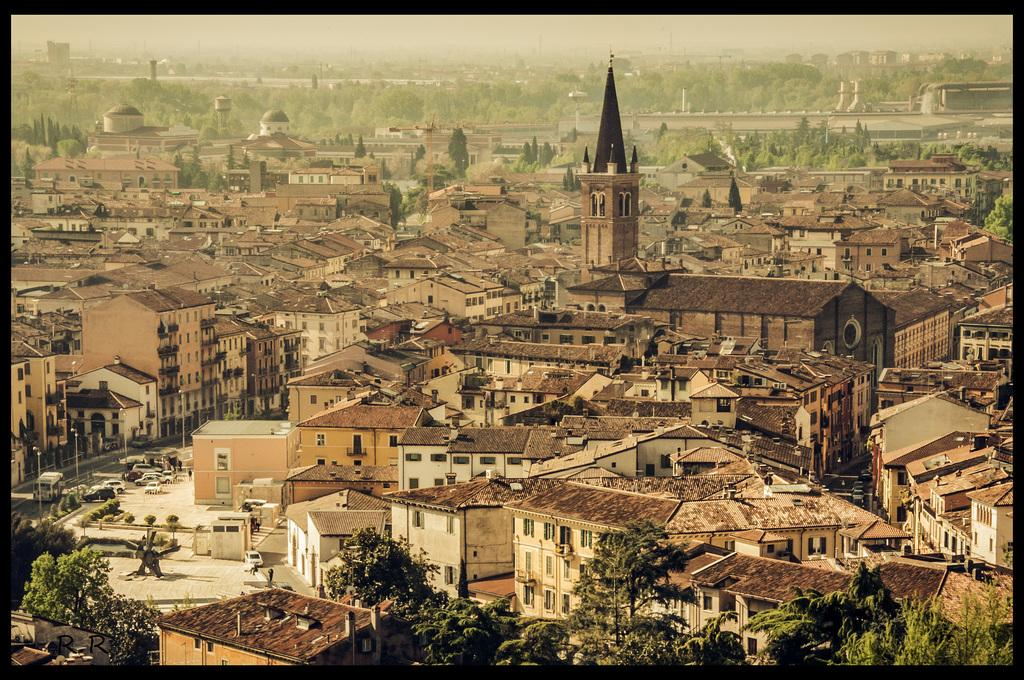What is the main subject of the image? The main subject of the image is a picture of a group of buildings. What specific features can be seen in the image? There are towers, vehicles on the road, street poles, and a group of trees visible in the image. What is visible in the background of the image? The sky is visible in the image. What type of play is being performed on the stage in the image? There is no stage or play present in the image; it features a picture of a group of buildings. What part of the city is depicted in the image? The image does not specify a particular part of the city; it simply shows a group of buildings, towers, vehicles, street poles, trees, and the sky. 